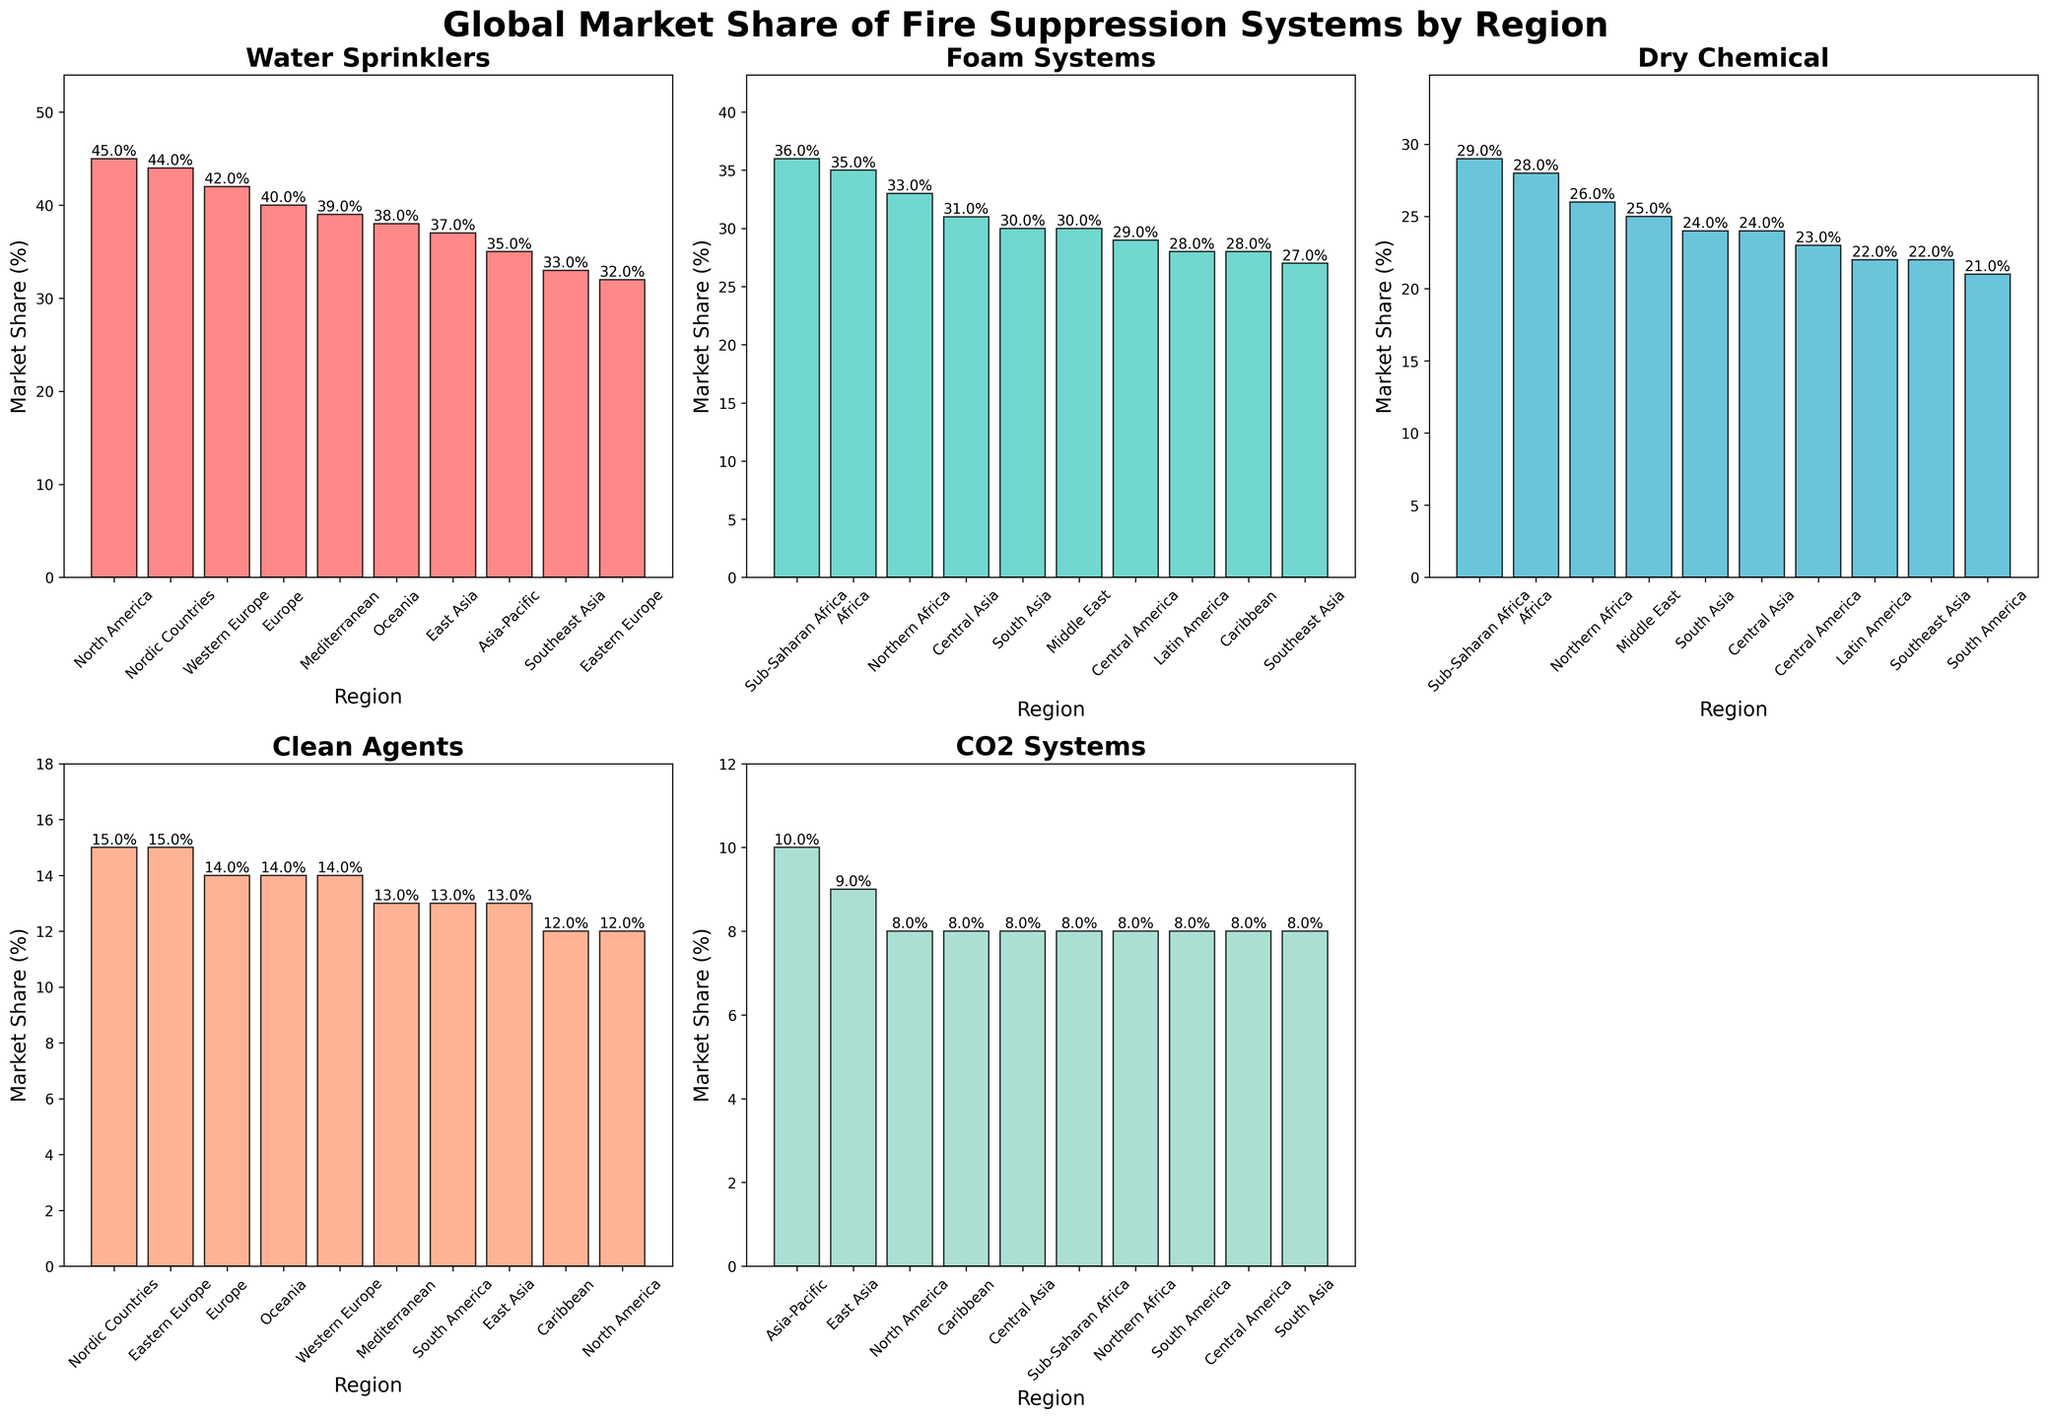Which region has the highest market share for Foam Systems? By examining the plot for Foam Systems, the region with the tallest bar represents the highest market share. The label on this bar is Africa.
Answer: Africa What's the total market share of Water Sprinklers in North America and Europe combined? From the Water Sprinklers subplot, identify the market share for North America (45%) and Europe (40%). Adding these values together gives 45 + 40 = 85.
Answer: 85 Which region has a higher market share for Dry Chemical systems, Latin America or Southeast Asia? By comparing the heights of the bars in the Dry Chemical subplot for Latin America (22%) and Southeast Asia (22%), both regions have the same market share.
Answer: Equal What's the difference in market share between the highest and lowest regions for CO2 Systems? In the CO2 Systems subplot, identify the highest value (East Asia at 9%) and the lowest value (Nordic Countries at 7%), then subtract the lowest value from the highest value: 9 - 7 = 2.
Answer: 2 Which system shows the most diverse market share distribution across regions? Visually compare each subplot to identify the system with the most variation in bar heights. Foam Systems show a wide range of market shares with clearly varied bar heights across regions.
Answer: Foam Systems 